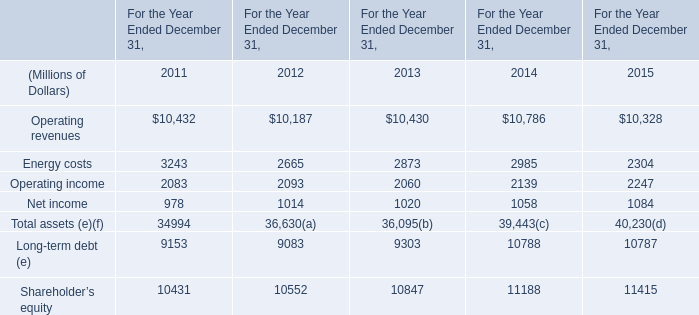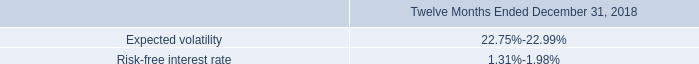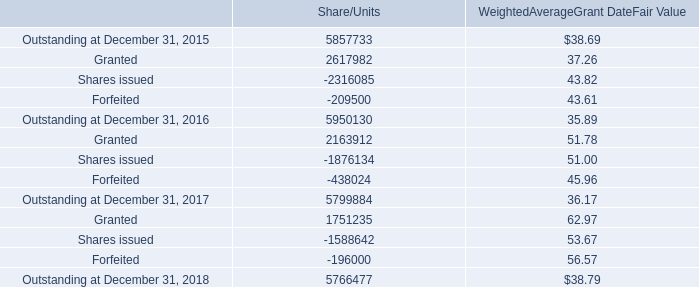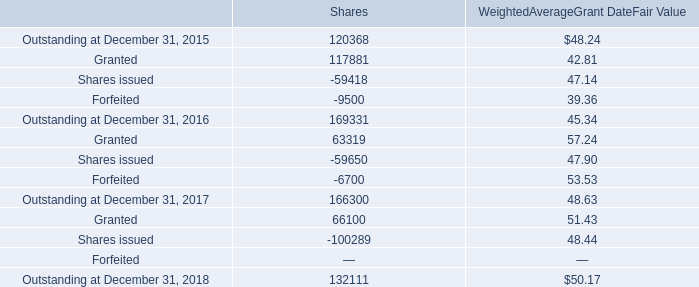What's the average of Outstanding at December 31, 2018 of Shares, and Outstanding at December 31, 2015 of Share/Units ? 
Computations: ((132111.0 + 5857733.0) / 2)
Answer: 2994922.0. What is the average amount of Energy costs of For the Year Ended December 31, 2015, and Outstanding at December 31, 2017 of Shares ? 
Computations: ((2304.0 + 166300.0) / 2)
Answer: 84302.0. 